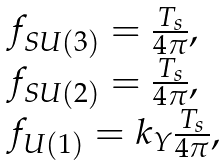<formula> <loc_0><loc_0><loc_500><loc_500>\begin{array} { l } f _ { S U ( 3 ) } = \frac { T _ { s } } { 4 \pi } , \\ f _ { S U ( 2 ) } = \frac { T _ { s } } { 4 \pi } , \\ f _ { U ( 1 ) } = k _ { Y } \frac { T _ { s } } { 4 \pi } , \end{array}</formula> 